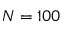Convert formula to latex. <formula><loc_0><loc_0><loc_500><loc_500>N = 1 0 0</formula> 